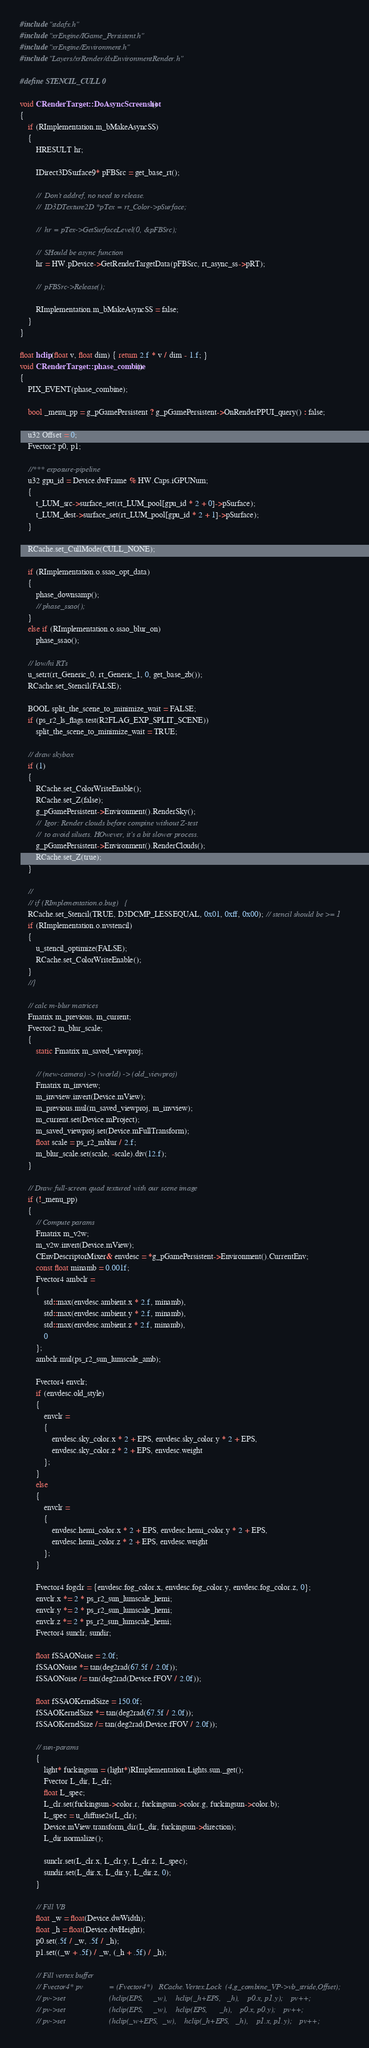Convert code to text. <code><loc_0><loc_0><loc_500><loc_500><_C++_>#include "stdafx.h"
#include "xrEngine/IGame_Persistent.h"
#include "xrEngine/Environment.h"
#include "Layers/xrRender/dxEnvironmentRender.h"

#define STENCIL_CULL 0

void CRenderTarget::DoAsyncScreenshot()
{
    if (RImplementation.m_bMakeAsyncSS)
    {
        HRESULT hr;

        IDirect3DSurface9* pFBSrc = get_base_rt();

        //  Don't addref, no need to release.
        //  ID3DTexture2D *pTex = rt_Color->pSurface;

        //  hr = pTex->GetSurfaceLevel(0, &pFBSrc);

        //  SHould be async function
        hr = HW.pDevice->GetRenderTargetData(pFBSrc, rt_async_ss->pRT);

        //  pFBSrc->Release();

        RImplementation.m_bMakeAsyncSS = false;
    }
}

float hclip(float v, float dim) { return 2.f * v / dim - 1.f; }
void CRenderTarget::phase_combine()
{
    PIX_EVENT(phase_combine);

    bool _menu_pp = g_pGamePersistent ? g_pGamePersistent->OnRenderPPUI_query() : false;

    u32 Offset = 0;
    Fvector2 p0, p1;

    //*** exposure-pipeline
    u32 gpu_id = Device.dwFrame % HW.Caps.iGPUNum;
    {
        t_LUM_src->surface_set(rt_LUM_pool[gpu_id * 2 + 0]->pSurface);
        t_LUM_dest->surface_set(rt_LUM_pool[gpu_id * 2 + 1]->pSurface);
    }

    RCache.set_CullMode(CULL_NONE);

    if (RImplementation.o.ssao_opt_data)
    {
        phase_downsamp();
        // phase_ssao();
    }
    else if (RImplementation.o.ssao_blur_on)
        phase_ssao();

    // low/hi RTs
    u_setrt(rt_Generic_0, rt_Generic_1, 0, get_base_zb());
    RCache.set_Stencil(FALSE);

    BOOL split_the_scene_to_minimize_wait = FALSE;
    if (ps_r2_ls_flags.test(R2FLAG_EXP_SPLIT_SCENE))
        split_the_scene_to_minimize_wait = TRUE;

    // draw skybox
    if (1)
    {
        RCache.set_ColorWriteEnable();
        RCache.set_Z(false);
        g_pGamePersistent->Environment().RenderSky();
        //  Igor: Render clouds before compine without Z-test
        //  to avoid siluets. HOwever, it's a bit slower process.
        g_pGamePersistent->Environment().RenderClouds();
        RCache.set_Z(true);
    }

    //
    // if (RImplementation.o.bug)   {
    RCache.set_Stencil(TRUE, D3DCMP_LESSEQUAL, 0x01, 0xff, 0x00); // stencil should be >= 1
    if (RImplementation.o.nvstencil)
    {
        u_stencil_optimize(FALSE);
        RCache.set_ColorWriteEnable();
    }
    //}

    // calc m-blur matrices
    Fmatrix m_previous, m_current;
    Fvector2 m_blur_scale;
    {
        static Fmatrix m_saved_viewproj;

        // (new-camera) -> (world) -> (old_viewproj)
        Fmatrix m_invview;
        m_invview.invert(Device.mView);
        m_previous.mul(m_saved_viewproj, m_invview);
        m_current.set(Device.mProject);
        m_saved_viewproj.set(Device.mFullTransform);
        float scale = ps_r2_mblur / 2.f;
        m_blur_scale.set(scale, -scale).div(12.f);
    }

    // Draw full-screen quad textured with our scene image
    if (!_menu_pp)
    {
        // Compute params
        Fmatrix m_v2w;
        m_v2w.invert(Device.mView);
        CEnvDescriptorMixer& envdesc = *g_pGamePersistent->Environment().CurrentEnv;
        const float minamb = 0.001f;
        Fvector4 ambclr =
        {
            std::max(envdesc.ambient.x * 2.f, minamb),
            std::max(envdesc.ambient.y * 2.f, minamb),
            std::max(envdesc.ambient.z * 2.f, minamb),
            0
        };
        ambclr.mul(ps_r2_sun_lumscale_amb);

        Fvector4 envclr;
        if (envdesc.old_style)
        {
            envclr =
            {
                envdesc.sky_color.x * 2 + EPS, envdesc.sky_color.y * 2 + EPS,
                envdesc.sky_color.z * 2 + EPS, envdesc.weight
            };
        }
        else
        {
            envclr =
            {
                envdesc.hemi_color.x * 2 + EPS, envdesc.hemi_color.y * 2 + EPS,
                envdesc.hemi_color.z * 2 + EPS, envdesc.weight
            };
        }

        Fvector4 fogclr = {envdesc.fog_color.x, envdesc.fog_color.y, envdesc.fog_color.z, 0};
        envclr.x *= 2 * ps_r2_sun_lumscale_hemi;
        envclr.y *= 2 * ps_r2_sun_lumscale_hemi;
        envclr.z *= 2 * ps_r2_sun_lumscale_hemi;
        Fvector4 sunclr, sundir;

        float fSSAONoise = 2.0f;
        fSSAONoise *= tan(deg2rad(67.5f / 2.0f));
        fSSAONoise /= tan(deg2rad(Device.fFOV / 2.0f));

        float fSSAOKernelSize = 150.0f;
        fSSAOKernelSize *= tan(deg2rad(67.5f / 2.0f));
        fSSAOKernelSize /= tan(deg2rad(Device.fFOV / 2.0f));

        // sun-params
        {
            light* fuckingsun = (light*)RImplementation.Lights.sun._get();
            Fvector L_dir, L_clr;
            float L_spec;
            L_clr.set(fuckingsun->color.r, fuckingsun->color.g, fuckingsun->color.b);
            L_spec = u_diffuse2s(L_clr);
            Device.mView.transform_dir(L_dir, fuckingsun->direction);
            L_dir.normalize();

            sunclr.set(L_clr.x, L_clr.y, L_clr.z, L_spec);
            sundir.set(L_dir.x, L_dir.y, L_dir.z, 0);
        }

        // Fill VB
        float _w = float(Device.dwWidth);
        float _h = float(Device.dwHeight);
        p0.set(.5f / _w, .5f / _h);
        p1.set((_w + .5f) / _w, (_h + .5f) / _h);

        // Fill vertex buffer
        // Fvector4* pv             = (Fvector4*)   RCache.Vertex.Lock  (4,g_combine_VP->vb_stride,Offset);
        // pv->set                      (hclip(EPS,     _w),    hclip(_h+EPS,   _h),    p0.x, p1.y);    pv++;
        // pv->set                      (hclip(EPS,     _w),    hclip(EPS,      _h),    p0.x, p0.y);    pv++;
        // pv->set                      (hclip(_w+EPS,  _w),    hclip(_h+EPS,   _h),    p1.x, p1.y);    pv++;</code> 